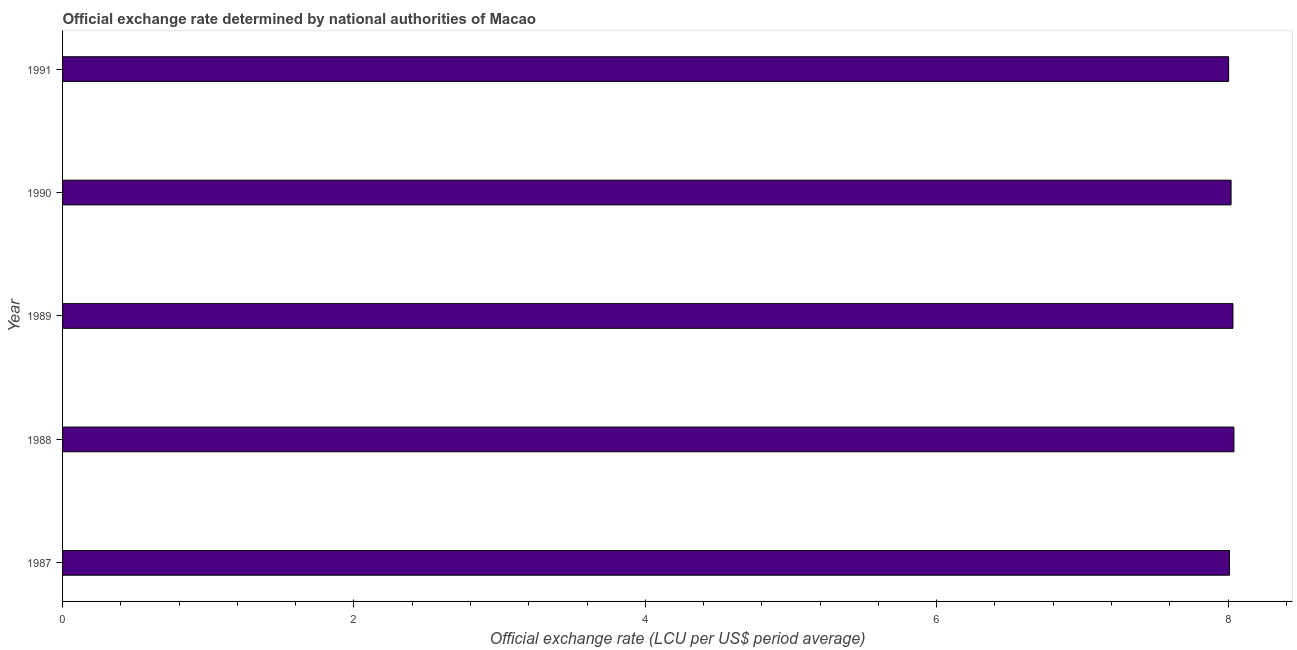Does the graph contain any zero values?
Provide a short and direct response. No. What is the title of the graph?
Offer a very short reply. Official exchange rate determined by national authorities of Macao. What is the label or title of the X-axis?
Provide a short and direct response. Official exchange rate (LCU per US$ period average). What is the label or title of the Y-axis?
Your response must be concise. Year. What is the official exchange rate in 1991?
Offer a terse response. 8. Across all years, what is the maximum official exchange rate?
Offer a terse response. 8.04. Across all years, what is the minimum official exchange rate?
Provide a succinct answer. 8. What is the sum of the official exchange rate?
Provide a short and direct response. 40.11. What is the difference between the official exchange rate in 1988 and 1989?
Offer a terse response. 0.01. What is the average official exchange rate per year?
Your answer should be very brief. 8.02. What is the median official exchange rate?
Your response must be concise. 8.02. In how many years, is the official exchange rate greater than 5.6 ?
Offer a very short reply. 5. Do a majority of the years between 1987 and 1988 (inclusive) have official exchange rate greater than 4 ?
Your response must be concise. Yes. Is the official exchange rate in 1988 less than that in 1991?
Keep it short and to the point. No. Is the difference between the official exchange rate in 1989 and 1991 greater than the difference between any two years?
Keep it short and to the point. No. What is the difference between the highest and the second highest official exchange rate?
Offer a terse response. 0.01. What is the difference between the highest and the lowest official exchange rate?
Keep it short and to the point. 0.04. Are all the bars in the graph horizontal?
Your response must be concise. Yes. What is the difference between two consecutive major ticks on the X-axis?
Give a very brief answer. 2. What is the Official exchange rate (LCU per US$ period average) in 1987?
Provide a short and direct response. 8.01. What is the Official exchange rate (LCU per US$ period average) of 1988?
Your answer should be compact. 8.04. What is the Official exchange rate (LCU per US$ period average) in 1989?
Offer a very short reply. 8.03. What is the Official exchange rate (LCU per US$ period average) of 1990?
Ensure brevity in your answer.  8.02. What is the Official exchange rate (LCU per US$ period average) of 1991?
Your answer should be compact. 8. What is the difference between the Official exchange rate (LCU per US$ period average) in 1987 and 1988?
Your answer should be compact. -0.03. What is the difference between the Official exchange rate (LCU per US$ period average) in 1987 and 1989?
Give a very brief answer. -0.02. What is the difference between the Official exchange rate (LCU per US$ period average) in 1987 and 1990?
Offer a very short reply. -0.01. What is the difference between the Official exchange rate (LCU per US$ period average) in 1987 and 1991?
Your answer should be very brief. 0.01. What is the difference between the Official exchange rate (LCU per US$ period average) in 1988 and 1989?
Provide a short and direct response. 0.01. What is the difference between the Official exchange rate (LCU per US$ period average) in 1988 and 1990?
Keep it short and to the point. 0.02. What is the difference between the Official exchange rate (LCU per US$ period average) in 1988 and 1991?
Keep it short and to the point. 0.04. What is the difference between the Official exchange rate (LCU per US$ period average) in 1989 and 1990?
Offer a very short reply. 0.01. What is the difference between the Official exchange rate (LCU per US$ period average) in 1989 and 1991?
Offer a very short reply. 0.03. What is the difference between the Official exchange rate (LCU per US$ period average) in 1990 and 1991?
Your answer should be very brief. 0.02. What is the ratio of the Official exchange rate (LCU per US$ period average) in 1987 to that in 1988?
Your response must be concise. 1. What is the ratio of the Official exchange rate (LCU per US$ period average) in 1987 to that in 1989?
Give a very brief answer. 1. What is the ratio of the Official exchange rate (LCU per US$ period average) in 1987 to that in 1990?
Your response must be concise. 1. What is the ratio of the Official exchange rate (LCU per US$ period average) in 1987 to that in 1991?
Make the answer very short. 1. What is the ratio of the Official exchange rate (LCU per US$ period average) in 1988 to that in 1989?
Provide a succinct answer. 1. What is the ratio of the Official exchange rate (LCU per US$ period average) in 1989 to that in 1991?
Offer a very short reply. 1. 